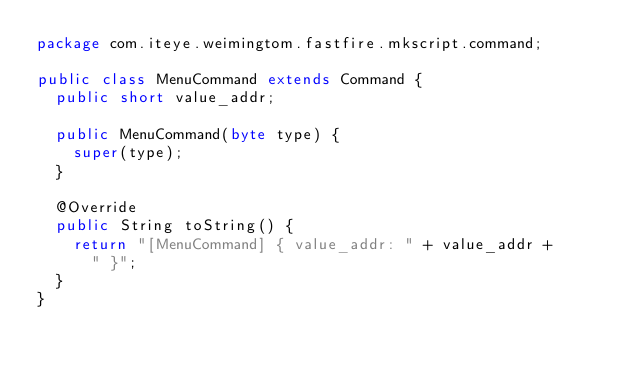Convert code to text. <code><loc_0><loc_0><loc_500><loc_500><_Java_>package com.iteye.weimingtom.fastfire.mkscript.command;

public class MenuCommand extends Command {
	public short value_addr;
	
	public MenuCommand(byte type) {
		super(type);
	}

	@Override
	public String toString() {
		return "[MenuCommand] { value_addr: " + value_addr +
			" }";
	}
}
</code> 